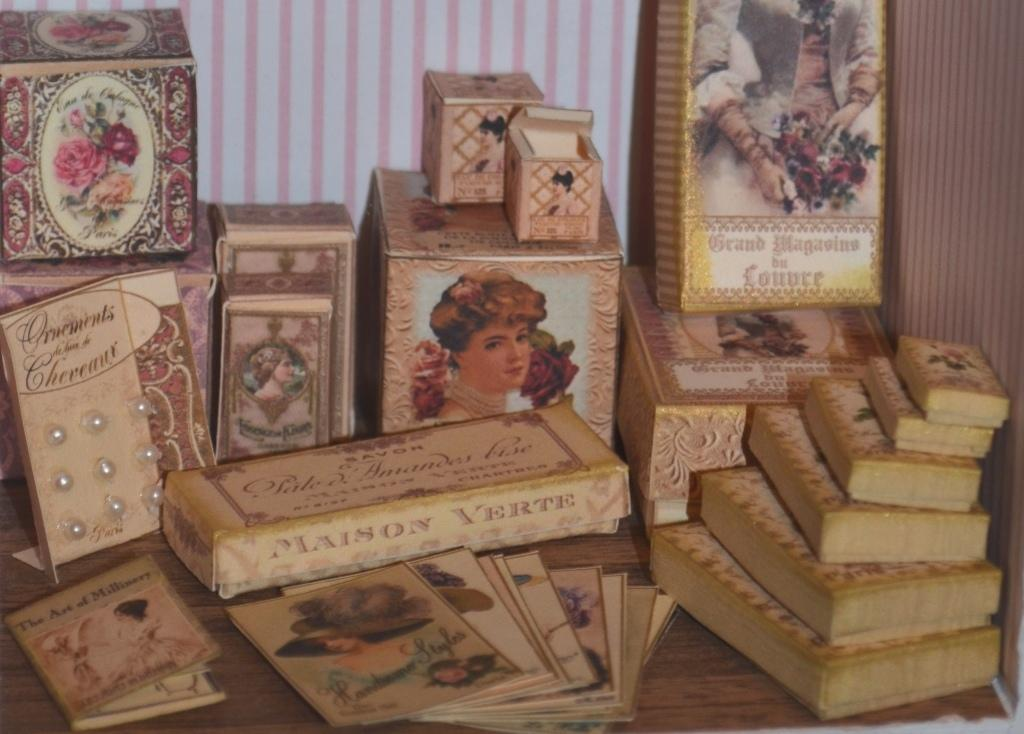<image>
Present a compact description of the photo's key features. Items on a table including a bar that says "Maison Verte" on it. 